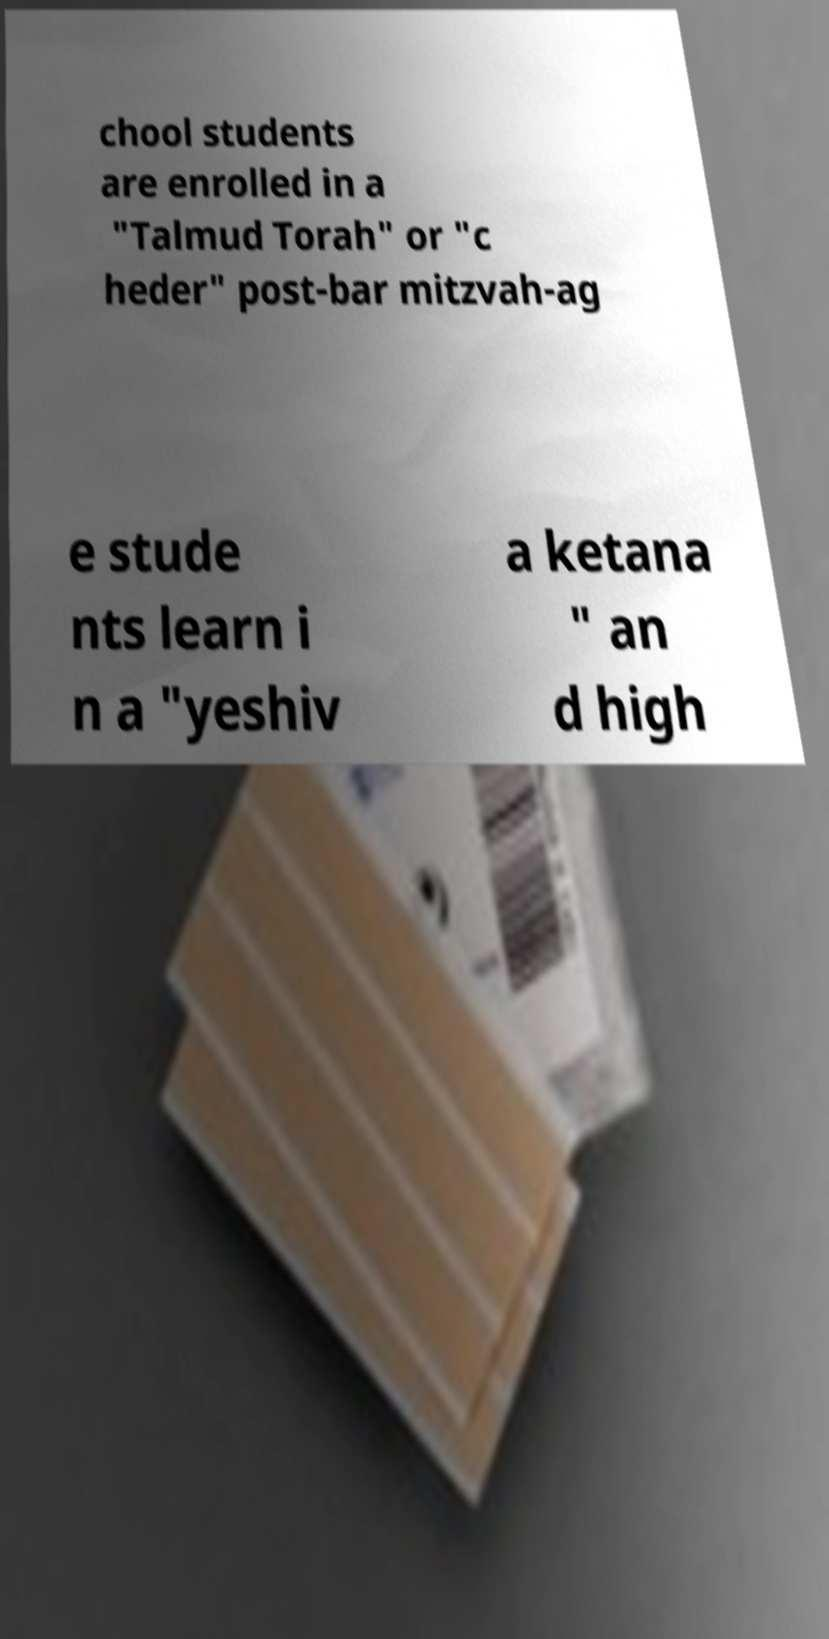Can you accurately transcribe the text from the provided image for me? chool students are enrolled in a "Talmud Torah" or "c heder" post-bar mitzvah-ag e stude nts learn i n a "yeshiv a ketana " an d high 